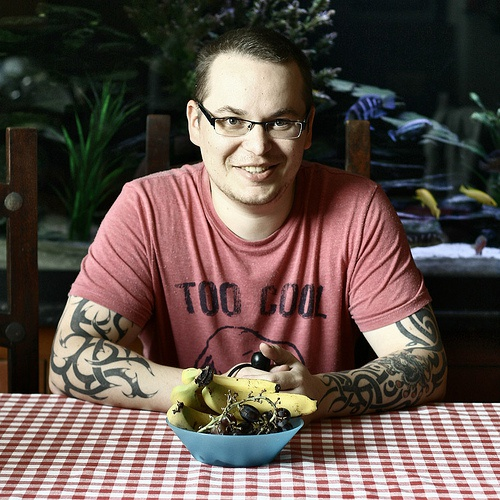Describe the objects in this image and their specific colors. I can see people in black, lightpink, brown, and maroon tones, dining table in black, lightgray, brown, pink, and darkgray tones, banana in black, khaki, and olive tones, chair in black, pink, and gray tones, and bowl in black, gray, teal, and blue tones in this image. 